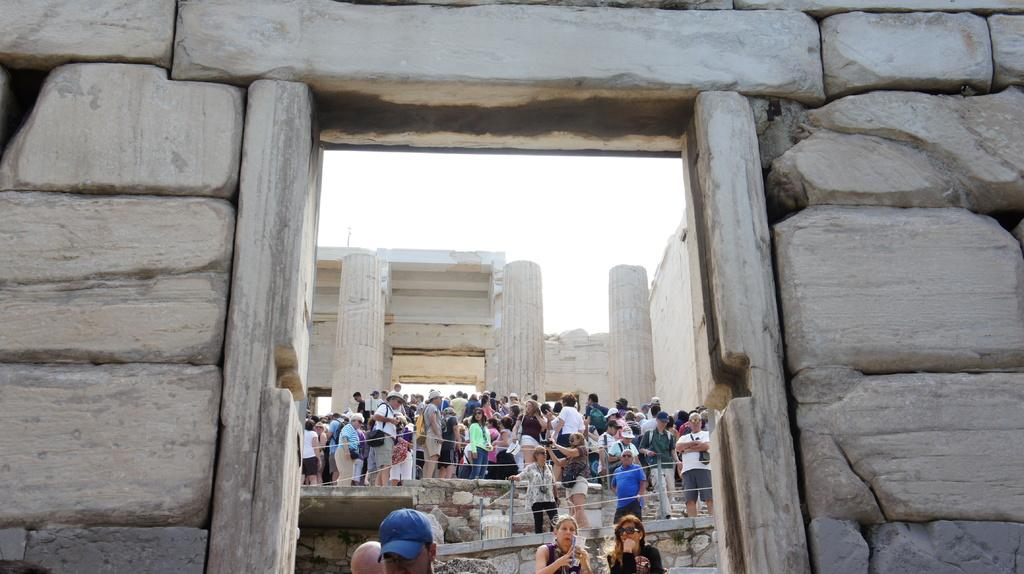What type of structure is visible in the image? There is a stone wall in the image. What feature is present in the stone wall? There is a door in the image. Are there any architectural elements in the image? Yes, there are pillars and walls visible in the image. What is the condition of the sky in the image? The sky is visible at the top of the image. How many people can be seen in the image? There are people standing in the image. What type of trucks are parked near the stone wall in the image? There are no trucks present in the image; it only features a stone wall, a door, pillars, walls, the sky, and people. What type of punishment is being administered to the people in the image? There is no indication of any punishment being administered in the image; it simply shows people standing near a stone wall. 